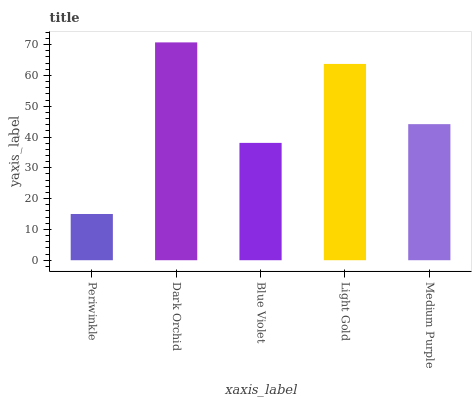Is Periwinkle the minimum?
Answer yes or no. Yes. Is Dark Orchid the maximum?
Answer yes or no. Yes. Is Blue Violet the minimum?
Answer yes or no. No. Is Blue Violet the maximum?
Answer yes or no. No. Is Dark Orchid greater than Blue Violet?
Answer yes or no. Yes. Is Blue Violet less than Dark Orchid?
Answer yes or no. Yes. Is Blue Violet greater than Dark Orchid?
Answer yes or no. No. Is Dark Orchid less than Blue Violet?
Answer yes or no. No. Is Medium Purple the high median?
Answer yes or no. Yes. Is Medium Purple the low median?
Answer yes or no. Yes. Is Light Gold the high median?
Answer yes or no. No. Is Blue Violet the low median?
Answer yes or no. No. 